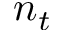<formula> <loc_0><loc_0><loc_500><loc_500>n _ { t }</formula> 